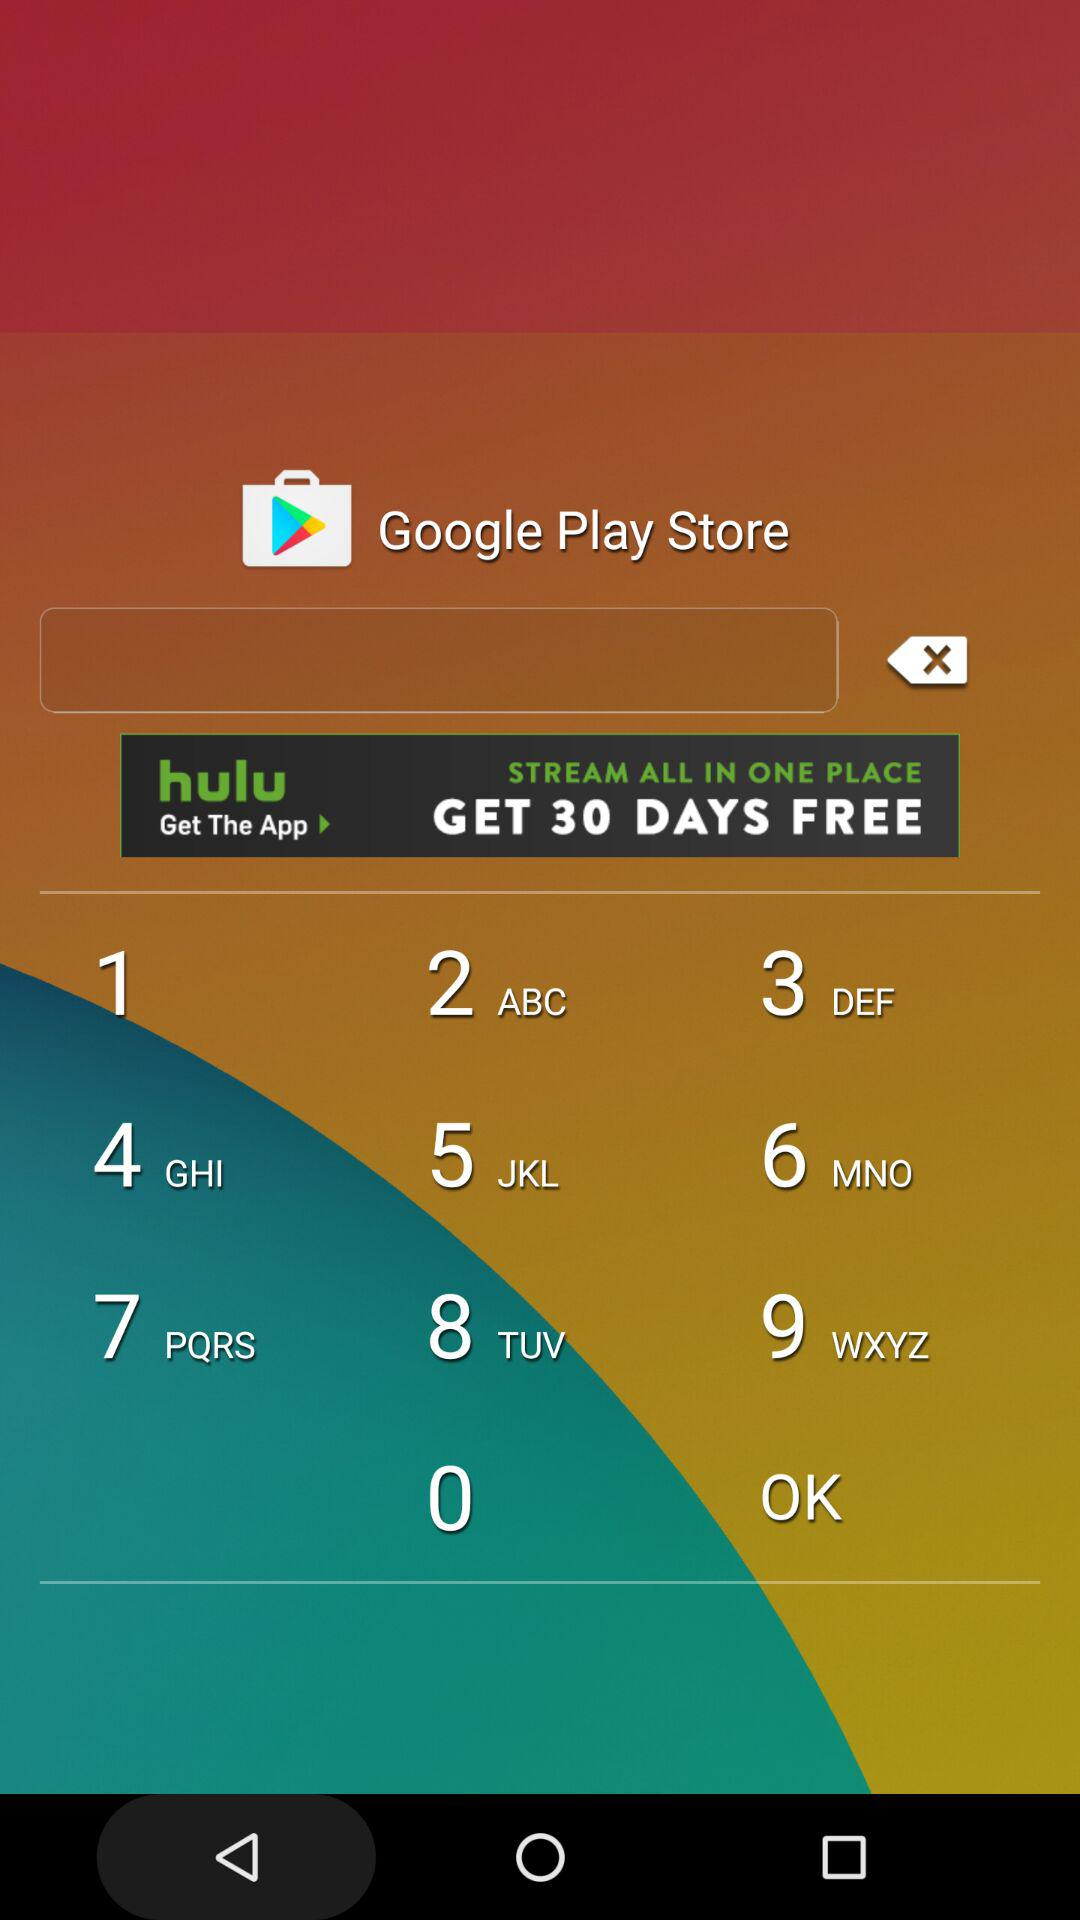What is the claim price for the "Starter Allowance" race? The claim price for the "Starter Allowance" race is $40,000. 